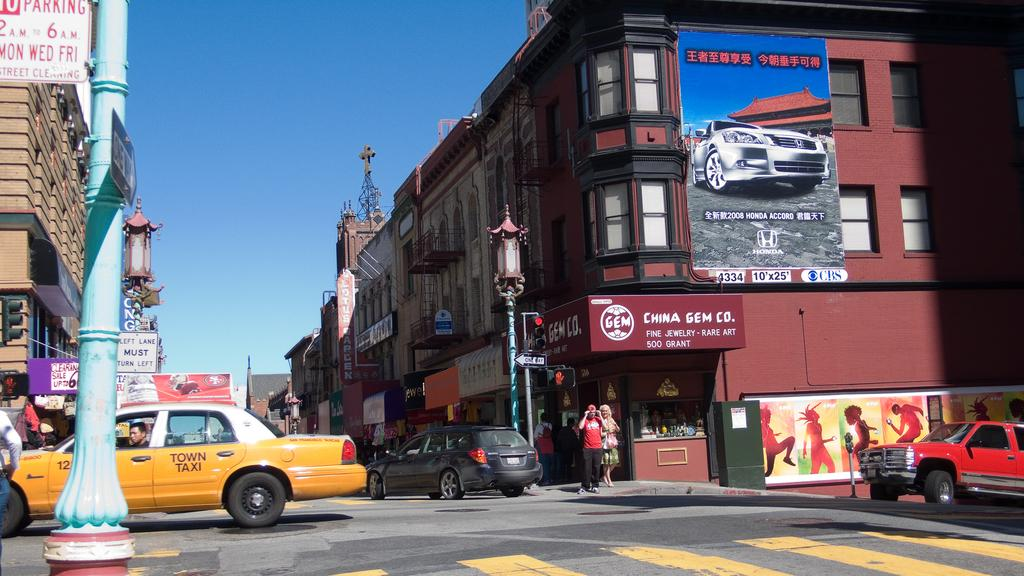<image>
Provide a brief description of the given image. People walk across a crosswalk in front of a yellow taxi in the city. 